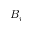Convert formula to latex. <formula><loc_0><loc_0><loc_500><loc_500>B _ { i }</formula> 